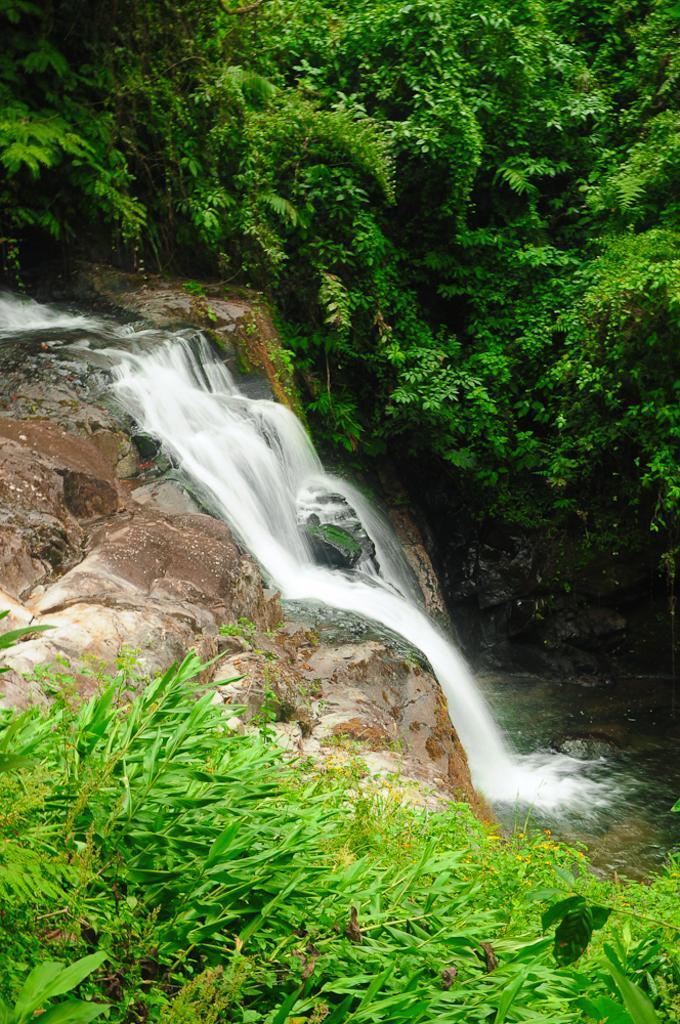Can you describe this image briefly? This picture is clicked outside the city. In the foreground we can see the plants. In the center there is a waterfall and we can see the rocks. On the right there is a water body. In the background we can see the trees. 